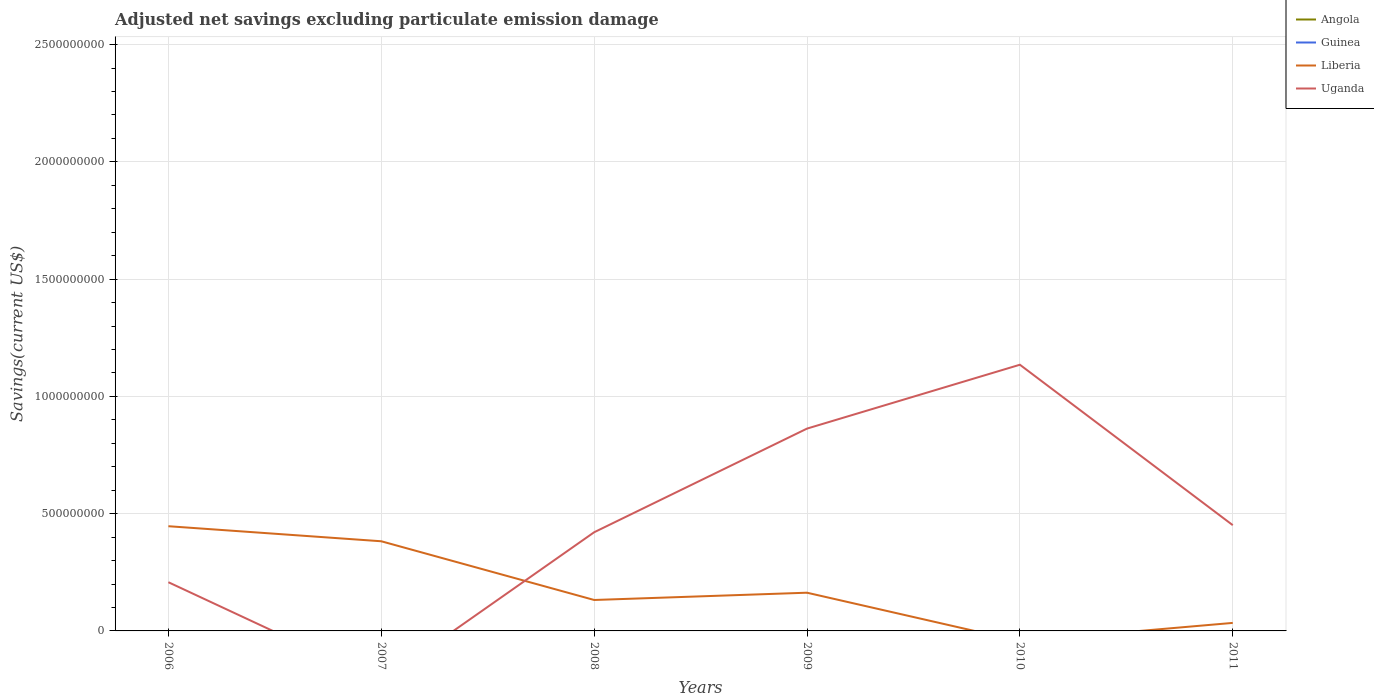Does the line corresponding to Angola intersect with the line corresponding to Uganda?
Offer a terse response. No. Is the number of lines equal to the number of legend labels?
Keep it short and to the point. No. Across all years, what is the maximum adjusted net savings in Angola?
Offer a very short reply. 0. What is the total adjusted net savings in Uganda in the graph?
Keep it short and to the point. -2.72e+08. What is the difference between the highest and the second highest adjusted net savings in Uganda?
Offer a very short reply. 1.14e+09. What is the difference between the highest and the lowest adjusted net savings in Guinea?
Offer a very short reply. 0. How many lines are there?
Provide a succinct answer. 2. Are the values on the major ticks of Y-axis written in scientific E-notation?
Keep it short and to the point. No. Does the graph contain grids?
Ensure brevity in your answer.  Yes. What is the title of the graph?
Provide a short and direct response. Adjusted net savings excluding particulate emission damage. Does "Dominica" appear as one of the legend labels in the graph?
Keep it short and to the point. No. What is the label or title of the X-axis?
Your answer should be very brief. Years. What is the label or title of the Y-axis?
Ensure brevity in your answer.  Savings(current US$). What is the Savings(current US$) in Angola in 2006?
Offer a terse response. 0. What is the Savings(current US$) in Guinea in 2006?
Offer a terse response. 0. What is the Savings(current US$) in Liberia in 2006?
Give a very brief answer. 4.46e+08. What is the Savings(current US$) of Uganda in 2006?
Provide a short and direct response. 2.08e+08. What is the Savings(current US$) in Guinea in 2007?
Your response must be concise. 0. What is the Savings(current US$) of Liberia in 2007?
Offer a terse response. 3.82e+08. What is the Savings(current US$) of Uganda in 2007?
Provide a succinct answer. 0. What is the Savings(current US$) in Guinea in 2008?
Give a very brief answer. 0. What is the Savings(current US$) in Liberia in 2008?
Make the answer very short. 1.32e+08. What is the Savings(current US$) in Uganda in 2008?
Provide a short and direct response. 4.21e+08. What is the Savings(current US$) in Angola in 2009?
Give a very brief answer. 0. What is the Savings(current US$) of Liberia in 2009?
Provide a short and direct response. 1.63e+08. What is the Savings(current US$) of Uganda in 2009?
Offer a very short reply. 8.63e+08. What is the Savings(current US$) of Uganda in 2010?
Offer a terse response. 1.14e+09. What is the Savings(current US$) of Guinea in 2011?
Your answer should be very brief. 0. What is the Savings(current US$) in Liberia in 2011?
Your answer should be compact. 3.42e+07. What is the Savings(current US$) of Uganda in 2011?
Offer a terse response. 4.51e+08. Across all years, what is the maximum Savings(current US$) of Liberia?
Your answer should be compact. 4.46e+08. Across all years, what is the maximum Savings(current US$) of Uganda?
Offer a very short reply. 1.14e+09. Across all years, what is the minimum Savings(current US$) of Liberia?
Your answer should be compact. 0. Across all years, what is the minimum Savings(current US$) of Uganda?
Keep it short and to the point. 0. What is the total Savings(current US$) of Liberia in the graph?
Your response must be concise. 1.16e+09. What is the total Savings(current US$) in Uganda in the graph?
Provide a succinct answer. 3.08e+09. What is the difference between the Savings(current US$) in Liberia in 2006 and that in 2007?
Your response must be concise. 6.42e+07. What is the difference between the Savings(current US$) of Liberia in 2006 and that in 2008?
Offer a very short reply. 3.15e+08. What is the difference between the Savings(current US$) in Uganda in 2006 and that in 2008?
Offer a very short reply. -2.13e+08. What is the difference between the Savings(current US$) of Liberia in 2006 and that in 2009?
Ensure brevity in your answer.  2.84e+08. What is the difference between the Savings(current US$) in Uganda in 2006 and that in 2009?
Give a very brief answer. -6.55e+08. What is the difference between the Savings(current US$) in Uganda in 2006 and that in 2010?
Keep it short and to the point. -9.27e+08. What is the difference between the Savings(current US$) in Liberia in 2006 and that in 2011?
Ensure brevity in your answer.  4.12e+08. What is the difference between the Savings(current US$) in Uganda in 2006 and that in 2011?
Offer a very short reply. -2.43e+08. What is the difference between the Savings(current US$) in Liberia in 2007 and that in 2008?
Provide a succinct answer. 2.50e+08. What is the difference between the Savings(current US$) in Liberia in 2007 and that in 2009?
Ensure brevity in your answer.  2.19e+08. What is the difference between the Savings(current US$) of Liberia in 2007 and that in 2011?
Offer a very short reply. 3.48e+08. What is the difference between the Savings(current US$) of Liberia in 2008 and that in 2009?
Offer a terse response. -3.10e+07. What is the difference between the Savings(current US$) in Uganda in 2008 and that in 2009?
Your answer should be compact. -4.42e+08. What is the difference between the Savings(current US$) of Uganda in 2008 and that in 2010?
Your answer should be very brief. -7.14e+08. What is the difference between the Savings(current US$) of Liberia in 2008 and that in 2011?
Make the answer very short. 9.77e+07. What is the difference between the Savings(current US$) in Uganda in 2008 and that in 2011?
Your answer should be very brief. -3.02e+07. What is the difference between the Savings(current US$) of Uganda in 2009 and that in 2010?
Keep it short and to the point. -2.72e+08. What is the difference between the Savings(current US$) of Liberia in 2009 and that in 2011?
Keep it short and to the point. 1.29e+08. What is the difference between the Savings(current US$) of Uganda in 2009 and that in 2011?
Offer a very short reply. 4.12e+08. What is the difference between the Savings(current US$) of Uganda in 2010 and that in 2011?
Provide a succinct answer. 6.84e+08. What is the difference between the Savings(current US$) in Liberia in 2006 and the Savings(current US$) in Uganda in 2008?
Your response must be concise. 2.58e+07. What is the difference between the Savings(current US$) in Liberia in 2006 and the Savings(current US$) in Uganda in 2009?
Provide a succinct answer. -4.16e+08. What is the difference between the Savings(current US$) of Liberia in 2006 and the Savings(current US$) of Uganda in 2010?
Keep it short and to the point. -6.89e+08. What is the difference between the Savings(current US$) in Liberia in 2006 and the Savings(current US$) in Uganda in 2011?
Your response must be concise. -4.46e+06. What is the difference between the Savings(current US$) in Liberia in 2007 and the Savings(current US$) in Uganda in 2008?
Keep it short and to the point. -3.84e+07. What is the difference between the Savings(current US$) of Liberia in 2007 and the Savings(current US$) of Uganda in 2009?
Your response must be concise. -4.80e+08. What is the difference between the Savings(current US$) of Liberia in 2007 and the Savings(current US$) of Uganda in 2010?
Ensure brevity in your answer.  -7.53e+08. What is the difference between the Savings(current US$) in Liberia in 2007 and the Savings(current US$) in Uganda in 2011?
Keep it short and to the point. -6.86e+07. What is the difference between the Savings(current US$) of Liberia in 2008 and the Savings(current US$) of Uganda in 2009?
Make the answer very short. -7.31e+08. What is the difference between the Savings(current US$) of Liberia in 2008 and the Savings(current US$) of Uganda in 2010?
Ensure brevity in your answer.  -1.00e+09. What is the difference between the Savings(current US$) of Liberia in 2008 and the Savings(current US$) of Uganda in 2011?
Give a very brief answer. -3.19e+08. What is the difference between the Savings(current US$) of Liberia in 2009 and the Savings(current US$) of Uganda in 2010?
Offer a very short reply. -9.72e+08. What is the difference between the Savings(current US$) in Liberia in 2009 and the Savings(current US$) in Uganda in 2011?
Your answer should be very brief. -2.88e+08. What is the average Savings(current US$) of Guinea per year?
Your answer should be very brief. 0. What is the average Savings(current US$) in Liberia per year?
Make the answer very short. 1.93e+08. What is the average Savings(current US$) of Uganda per year?
Keep it short and to the point. 5.13e+08. In the year 2006, what is the difference between the Savings(current US$) of Liberia and Savings(current US$) of Uganda?
Your answer should be very brief. 2.39e+08. In the year 2008, what is the difference between the Savings(current US$) of Liberia and Savings(current US$) of Uganda?
Give a very brief answer. -2.89e+08. In the year 2009, what is the difference between the Savings(current US$) in Liberia and Savings(current US$) in Uganda?
Make the answer very short. -7.00e+08. In the year 2011, what is the difference between the Savings(current US$) of Liberia and Savings(current US$) of Uganda?
Your answer should be very brief. -4.17e+08. What is the ratio of the Savings(current US$) of Liberia in 2006 to that in 2007?
Provide a short and direct response. 1.17. What is the ratio of the Savings(current US$) in Liberia in 2006 to that in 2008?
Give a very brief answer. 3.38. What is the ratio of the Savings(current US$) in Uganda in 2006 to that in 2008?
Make the answer very short. 0.49. What is the ratio of the Savings(current US$) of Liberia in 2006 to that in 2009?
Make the answer very short. 2.74. What is the ratio of the Savings(current US$) of Uganda in 2006 to that in 2009?
Provide a succinct answer. 0.24. What is the ratio of the Savings(current US$) in Uganda in 2006 to that in 2010?
Make the answer very short. 0.18. What is the ratio of the Savings(current US$) in Liberia in 2006 to that in 2011?
Offer a very short reply. 13.05. What is the ratio of the Savings(current US$) of Uganda in 2006 to that in 2011?
Give a very brief answer. 0.46. What is the ratio of the Savings(current US$) in Liberia in 2007 to that in 2008?
Provide a short and direct response. 2.9. What is the ratio of the Savings(current US$) of Liberia in 2007 to that in 2009?
Your response must be concise. 2.35. What is the ratio of the Savings(current US$) of Liberia in 2007 to that in 2011?
Your response must be concise. 11.17. What is the ratio of the Savings(current US$) of Liberia in 2008 to that in 2009?
Keep it short and to the point. 0.81. What is the ratio of the Savings(current US$) of Uganda in 2008 to that in 2009?
Your response must be concise. 0.49. What is the ratio of the Savings(current US$) in Uganda in 2008 to that in 2010?
Provide a succinct answer. 0.37. What is the ratio of the Savings(current US$) of Liberia in 2008 to that in 2011?
Your answer should be compact. 3.86. What is the ratio of the Savings(current US$) of Uganda in 2008 to that in 2011?
Ensure brevity in your answer.  0.93. What is the ratio of the Savings(current US$) in Uganda in 2009 to that in 2010?
Ensure brevity in your answer.  0.76. What is the ratio of the Savings(current US$) of Liberia in 2009 to that in 2011?
Offer a terse response. 4.76. What is the ratio of the Savings(current US$) in Uganda in 2009 to that in 2011?
Give a very brief answer. 1.91. What is the ratio of the Savings(current US$) of Uganda in 2010 to that in 2011?
Offer a terse response. 2.52. What is the difference between the highest and the second highest Savings(current US$) in Liberia?
Ensure brevity in your answer.  6.42e+07. What is the difference between the highest and the second highest Savings(current US$) of Uganda?
Make the answer very short. 2.72e+08. What is the difference between the highest and the lowest Savings(current US$) in Liberia?
Provide a short and direct response. 4.46e+08. What is the difference between the highest and the lowest Savings(current US$) in Uganda?
Make the answer very short. 1.14e+09. 